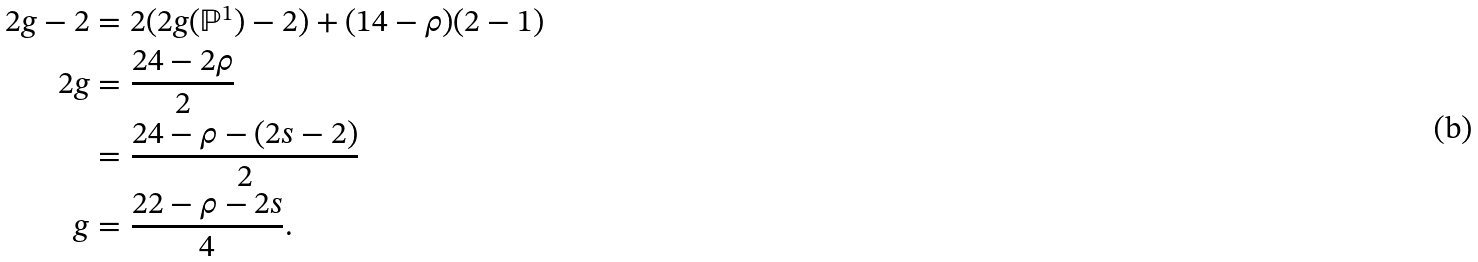Convert formula to latex. <formula><loc_0><loc_0><loc_500><loc_500>2 g - 2 & = 2 ( 2 g ( \mathbb { P } ^ { 1 } ) - 2 ) + ( 1 4 - \rho ) ( 2 - 1 ) \\ 2 g & = \frac { 2 4 - 2 \rho } { 2 } \\ & = \frac { 2 4 - \rho - ( 2 s - 2 ) } { 2 } \\ g & = \frac { 2 2 - \rho - 2 s } { 4 } .</formula> 